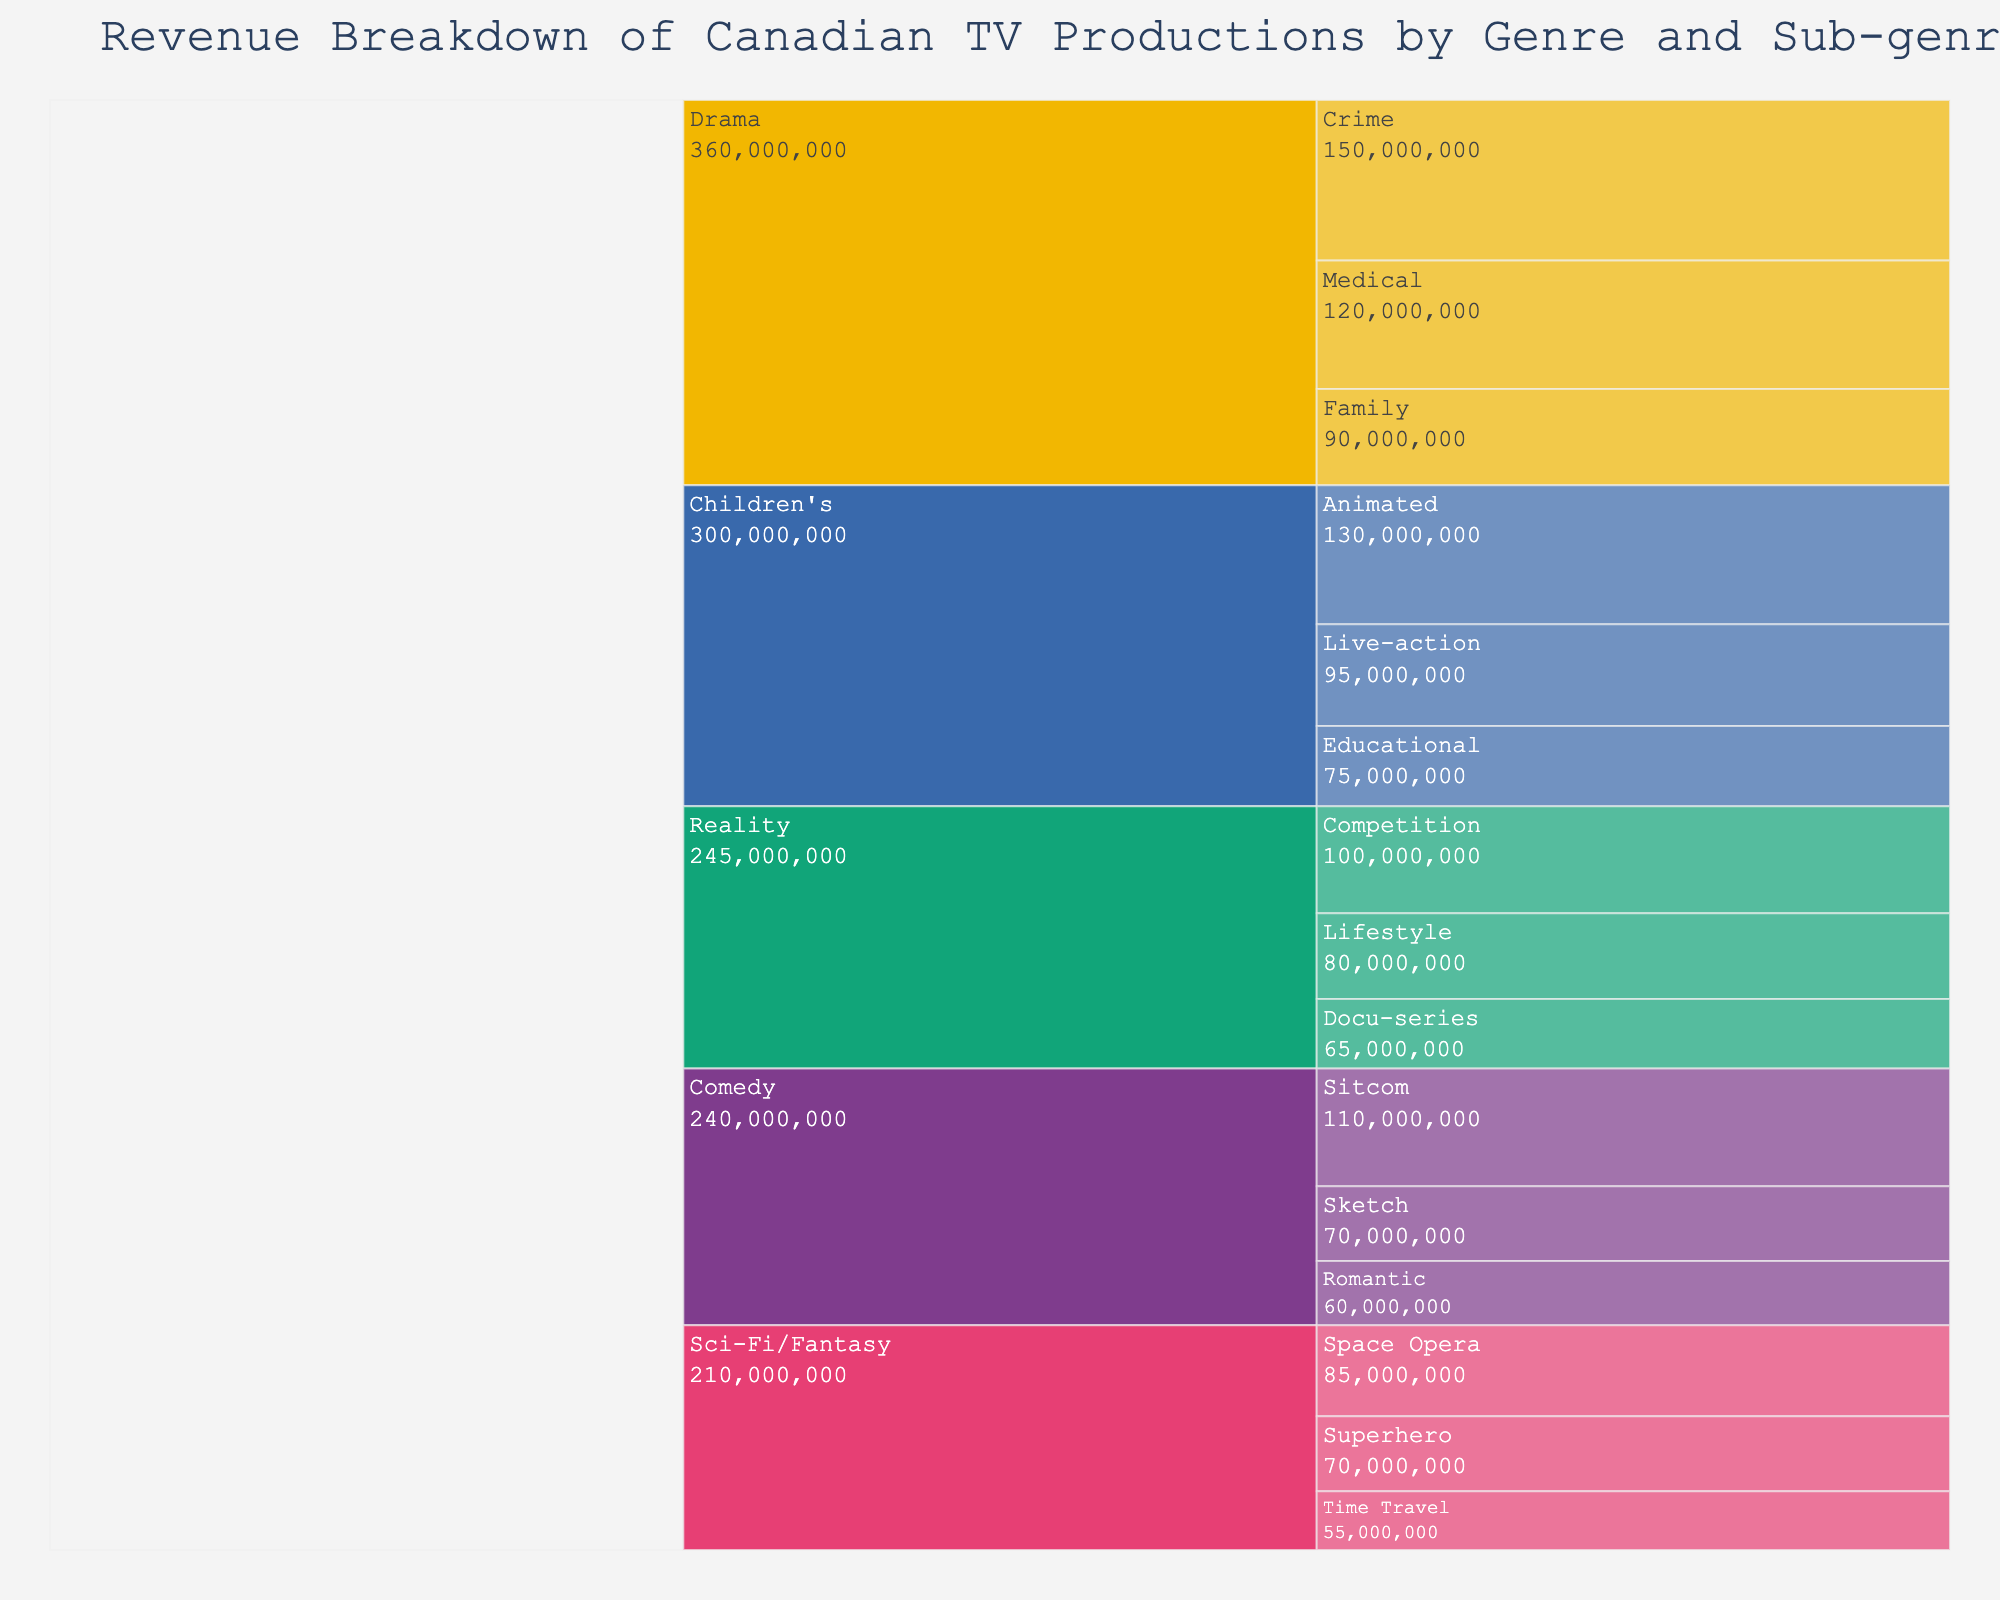What is the title of the figure? The title is located at the top of the figure in bold text.
Answer: Revenue Breakdown of Canadian TV Productions by Genre and Sub-genre Which genre has the highest revenue? Look at the largest colored section representing each genre.
Answer: Drama What is the revenue of the "Sitcom" subgenre? Locate "Sitcom" under the "Comedy" section and check its value.
Answer: $110,000,000 Which subgenre within "Children's" genre has the least revenue? Check the three sections under "Children's" and compare their values.
Answer: Educational What is the combined revenue of "Crime" and "Medical" subgenres within the "Drama" genre? Add the values of "Crime" and "Medical" subgenres. 150,000,000 + 120,000,000 = 270,000,000
Answer: $270,000,000 Between "Reality" and "Sci-Fi/Fantasy" genres, which one has higher total revenue? Sum up the revenue of all subgenres under each genre and compare the totals. Reality: 100,000,000 + 80,000,000 + 65,000,000 = 245,000,000. Sci-Fi/Fantasy: 85,000,000 + 70,000,000 + 55,000,000 = 210,000,000
Answer: Reality What is the difference in revenue between "Animated" and "Live-action" subgenres in "Children's" genre? Subtract the revenue of "Live-action" from "Animated". 130,000,000 - 95,000,000 = 35,000,000
Answer: $35,000,000 Which two subgenres within "Sci-Fi/Fantasy" have a combined revenue equal to "Competition" in "Reality"? Add the revenue of each two-subgenre combination in "Sci-Fi/Fantasy" and compare with "Competition". Space Opera + Time Travel: 85,000,000 + 55,000,000 = 140,000,000
Answer: Space Opera and Time Travel 